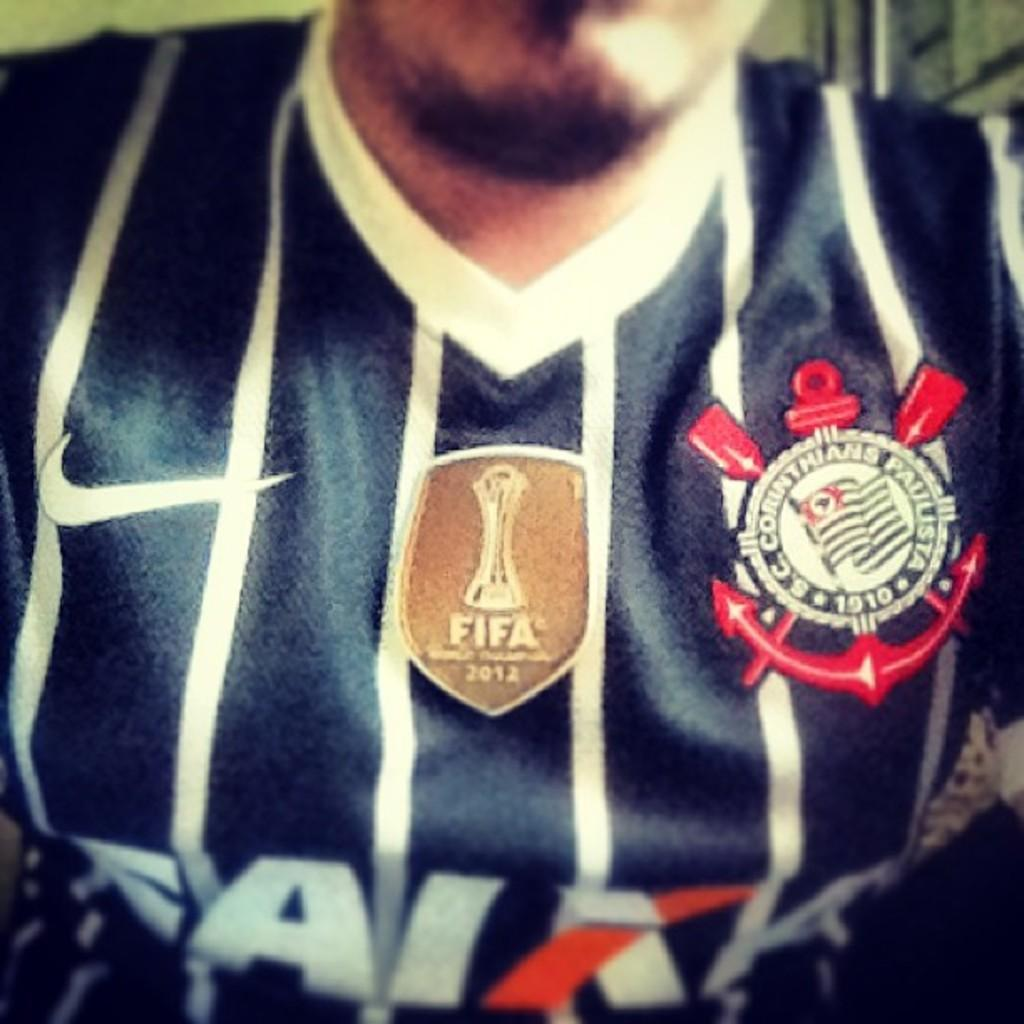<image>
Render a clear and concise summary of the photo. A person wears a jersey that has a patch about the 2012 FIFA world cup. 